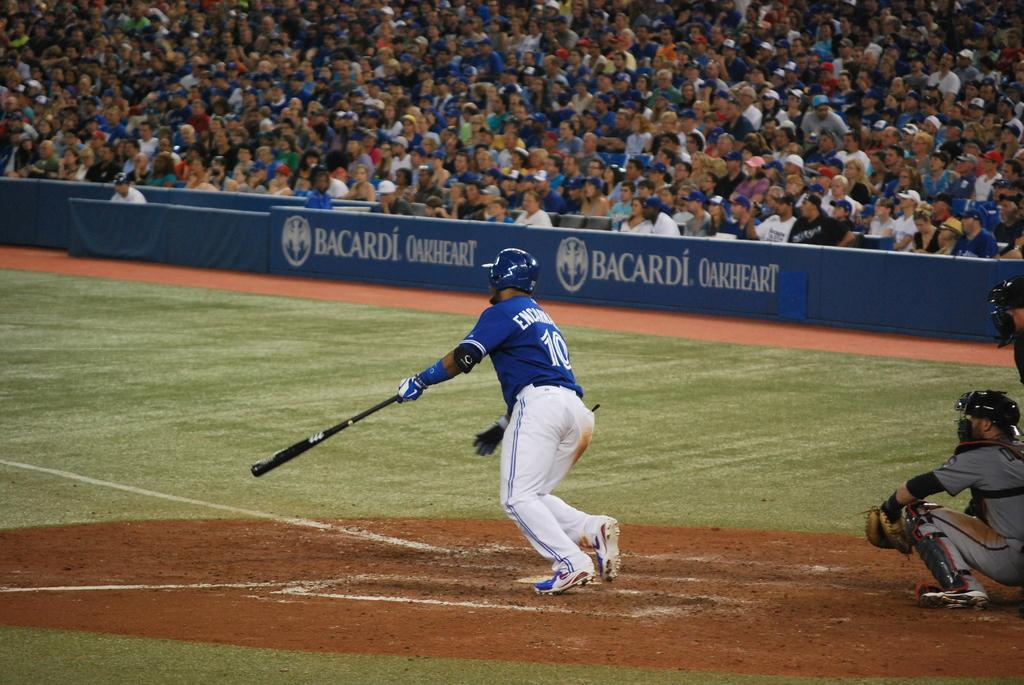<image>
Create a compact narrative representing the image presented. A baseball player in a blue #10 jersey hits the ball and starts to run. 